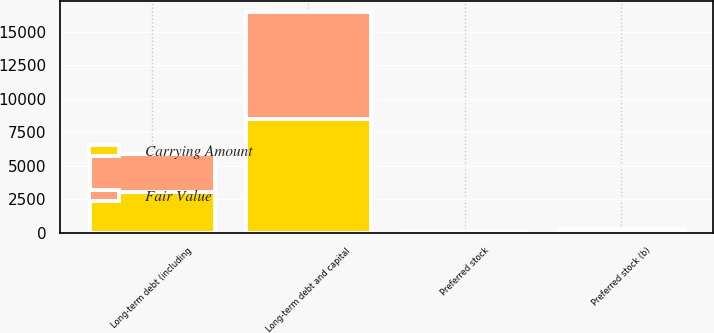<chart> <loc_0><loc_0><loc_500><loc_500><stacked_bar_chart><ecel><fcel>Long-term debt and capital<fcel>Preferred stock (b)<fcel>Preferred stock<fcel>Long-term debt (including<nl><fcel>Fair Value<fcel>7935<fcel>142<fcel>80<fcel>2830<nl><fcel>Carrying Amount<fcel>8531<fcel>131<fcel>80<fcel>3028<nl></chart> 